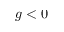Convert formula to latex. <formula><loc_0><loc_0><loc_500><loc_500>g < 0</formula> 